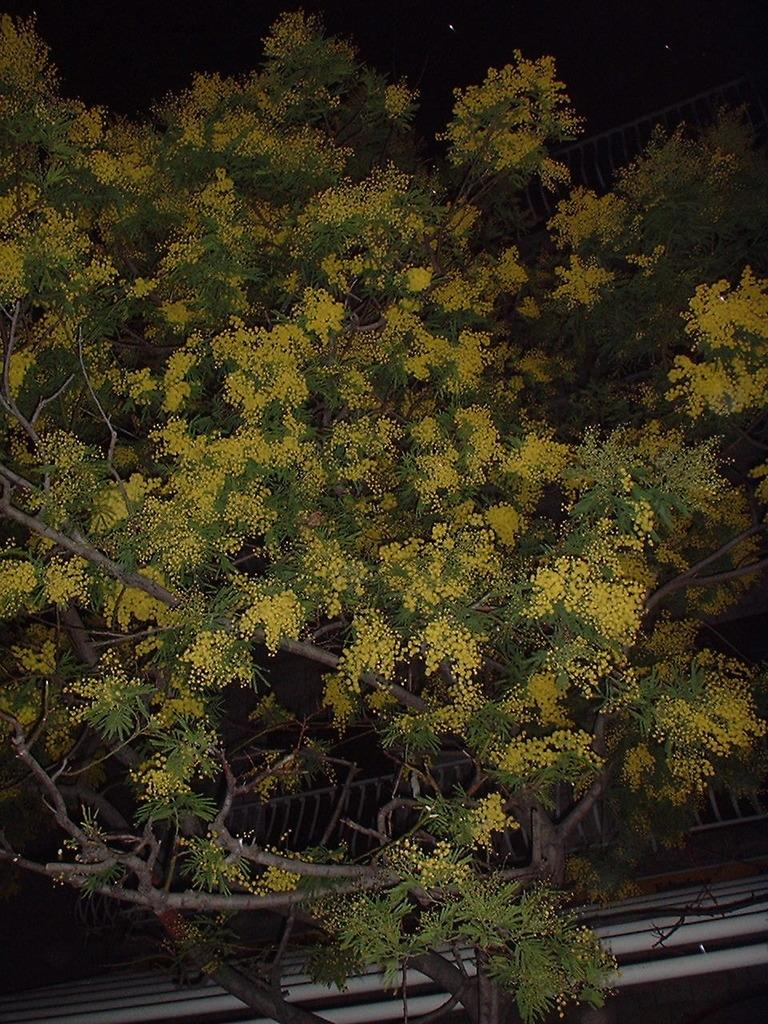What type of flowers can be seen on the tree in the image? There are yellow color flowers on a tree in the image. What structure is visible in the image? There is a railing visible in the image. What color is the background of the image? The background of the image is black. How many sisters are sitting on the railway in the image? There is no railway or sisters present in the image. What story is being told by the flowers in the image? The image does not depict a story; it simply shows yellow flowers on a tree. 